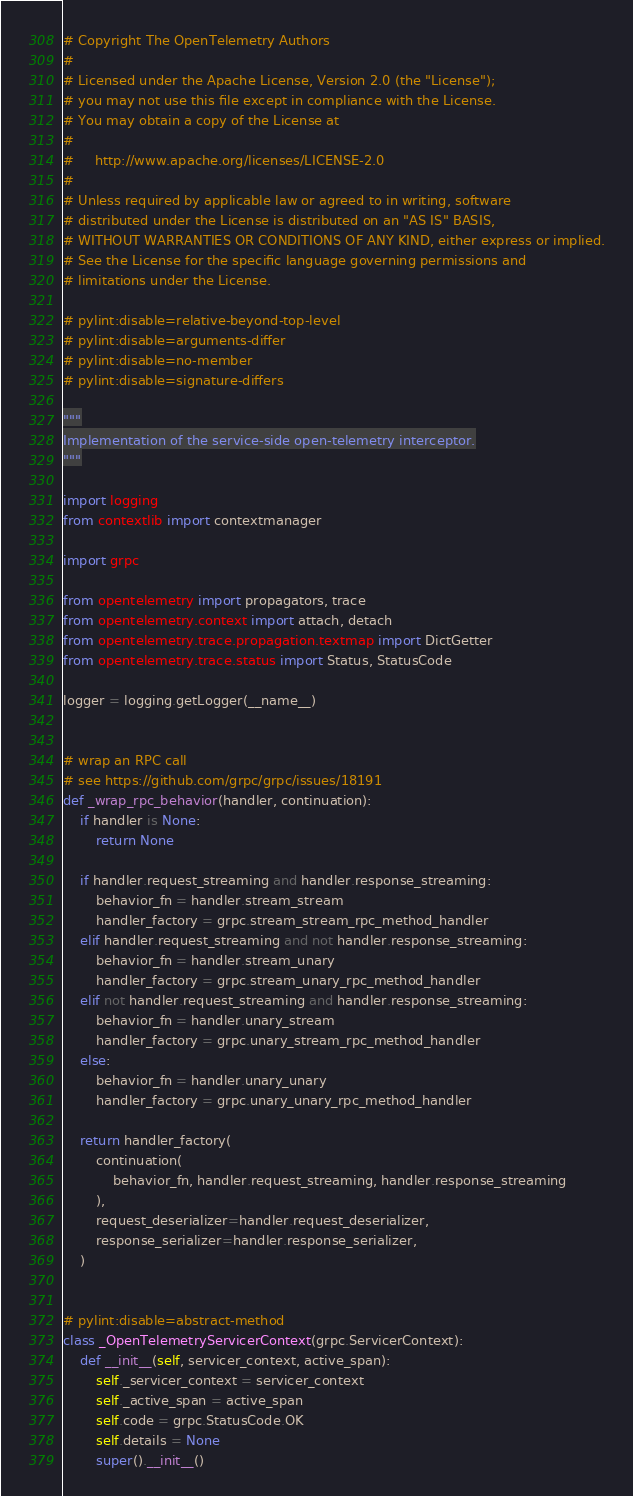<code> <loc_0><loc_0><loc_500><loc_500><_Python_># Copyright The OpenTelemetry Authors
#
# Licensed under the Apache License, Version 2.0 (the "License");
# you may not use this file except in compliance with the License.
# You may obtain a copy of the License at
#
#     http://www.apache.org/licenses/LICENSE-2.0
#
# Unless required by applicable law or agreed to in writing, software
# distributed under the License is distributed on an "AS IS" BASIS,
# WITHOUT WARRANTIES OR CONDITIONS OF ANY KIND, either express or implied.
# See the License for the specific language governing permissions and
# limitations under the License.

# pylint:disable=relative-beyond-top-level
# pylint:disable=arguments-differ
# pylint:disable=no-member
# pylint:disable=signature-differs

"""
Implementation of the service-side open-telemetry interceptor.
"""

import logging
from contextlib import contextmanager

import grpc

from opentelemetry import propagators, trace
from opentelemetry.context import attach, detach
from opentelemetry.trace.propagation.textmap import DictGetter
from opentelemetry.trace.status import Status, StatusCode

logger = logging.getLogger(__name__)


# wrap an RPC call
# see https://github.com/grpc/grpc/issues/18191
def _wrap_rpc_behavior(handler, continuation):
    if handler is None:
        return None

    if handler.request_streaming and handler.response_streaming:
        behavior_fn = handler.stream_stream
        handler_factory = grpc.stream_stream_rpc_method_handler
    elif handler.request_streaming and not handler.response_streaming:
        behavior_fn = handler.stream_unary
        handler_factory = grpc.stream_unary_rpc_method_handler
    elif not handler.request_streaming and handler.response_streaming:
        behavior_fn = handler.unary_stream
        handler_factory = grpc.unary_stream_rpc_method_handler
    else:
        behavior_fn = handler.unary_unary
        handler_factory = grpc.unary_unary_rpc_method_handler

    return handler_factory(
        continuation(
            behavior_fn, handler.request_streaming, handler.response_streaming
        ),
        request_deserializer=handler.request_deserializer,
        response_serializer=handler.response_serializer,
    )


# pylint:disable=abstract-method
class _OpenTelemetryServicerContext(grpc.ServicerContext):
    def __init__(self, servicer_context, active_span):
        self._servicer_context = servicer_context
        self._active_span = active_span
        self.code = grpc.StatusCode.OK
        self.details = None
        super().__init__()
</code> 